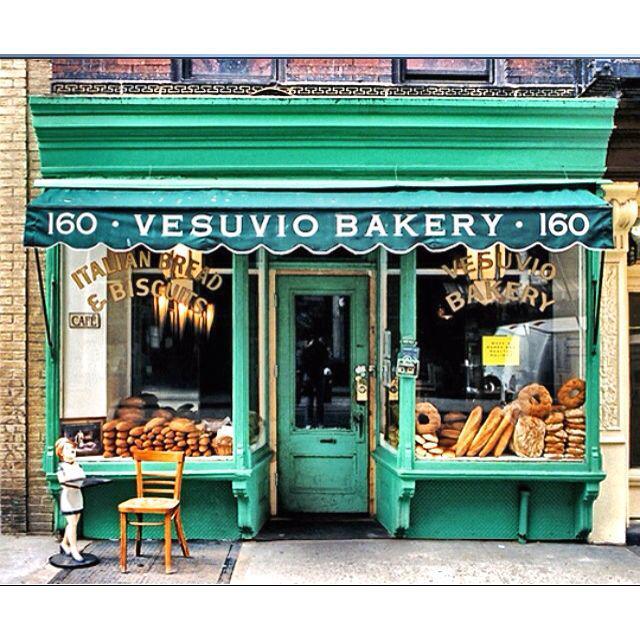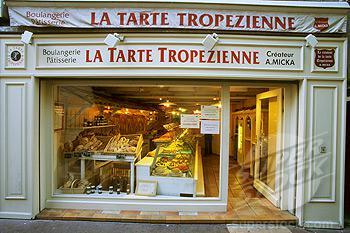The first image is the image on the left, the second image is the image on the right. Analyze the images presented: Is the assertion "The front door is wide open in some of the pictures." valid? Answer yes or no. Yes. The first image is the image on the left, the second image is the image on the right. For the images displayed, is the sentence "There is at least one chair outside in front of a building." factually correct? Answer yes or no. Yes. 